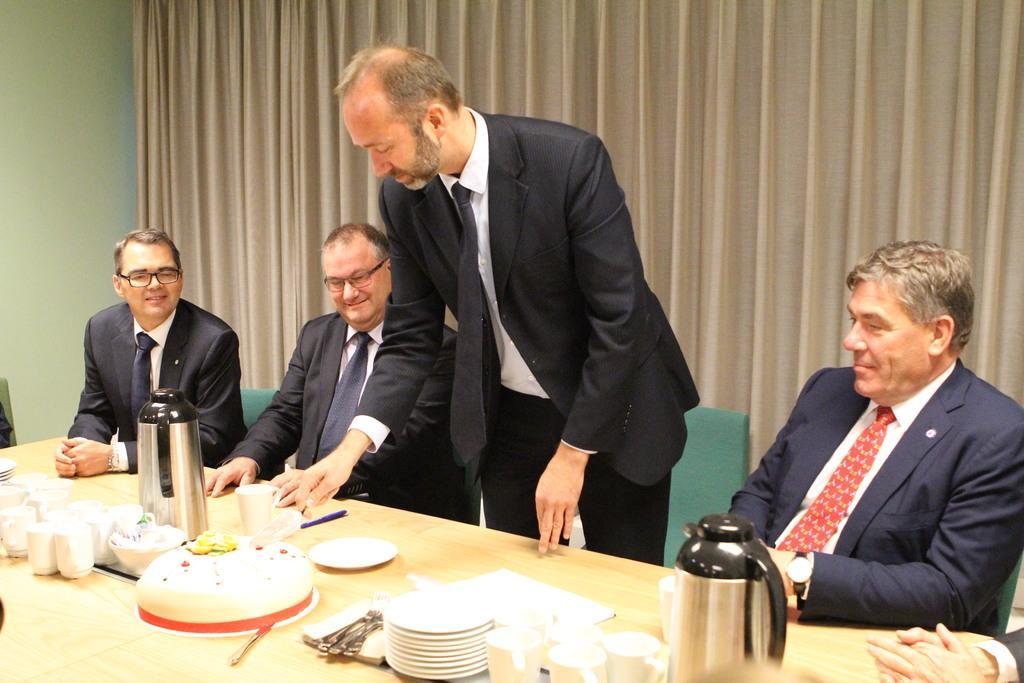How would you summarize this image in a sentence or two? This image is clicked in a room where on the top there is a curtain and there is a table in the bottom. There are chairs in the middle on which people are sitting. On the tables there is a cake, cups, plates, kettle, pen, paper, spoons. 